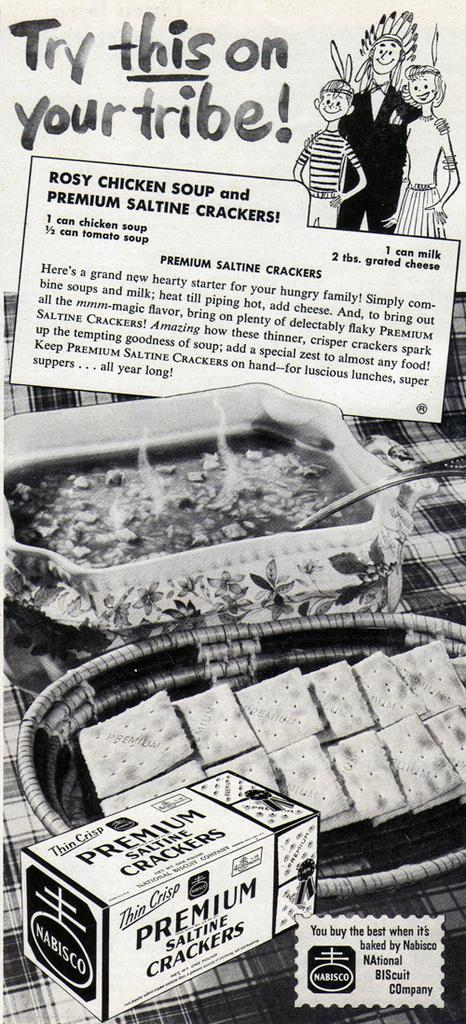What is the color scheme of the image? The image is black and white. What can be seen on the plates in the image? There are food items in plates in the image. Where are the spoons located in the image? Spoons are visible on a platform in the image. What type of illustrations are present in the image? There are cartoon pictures in the image. What is used for conveying information in the image? Text is present in the image. What is depicted as a separate object in the image? There is a picture of a box in the image. What type of fruit is hanging from the structure in the image? There is no fruit or structure present in the image; it is a black and white image with food items, spoons, cartoon pictures, text, and a picture of a box. What is the weight of the box in the image? The weight of the box cannot be determined from the image, as it is a two-dimensional representation. 